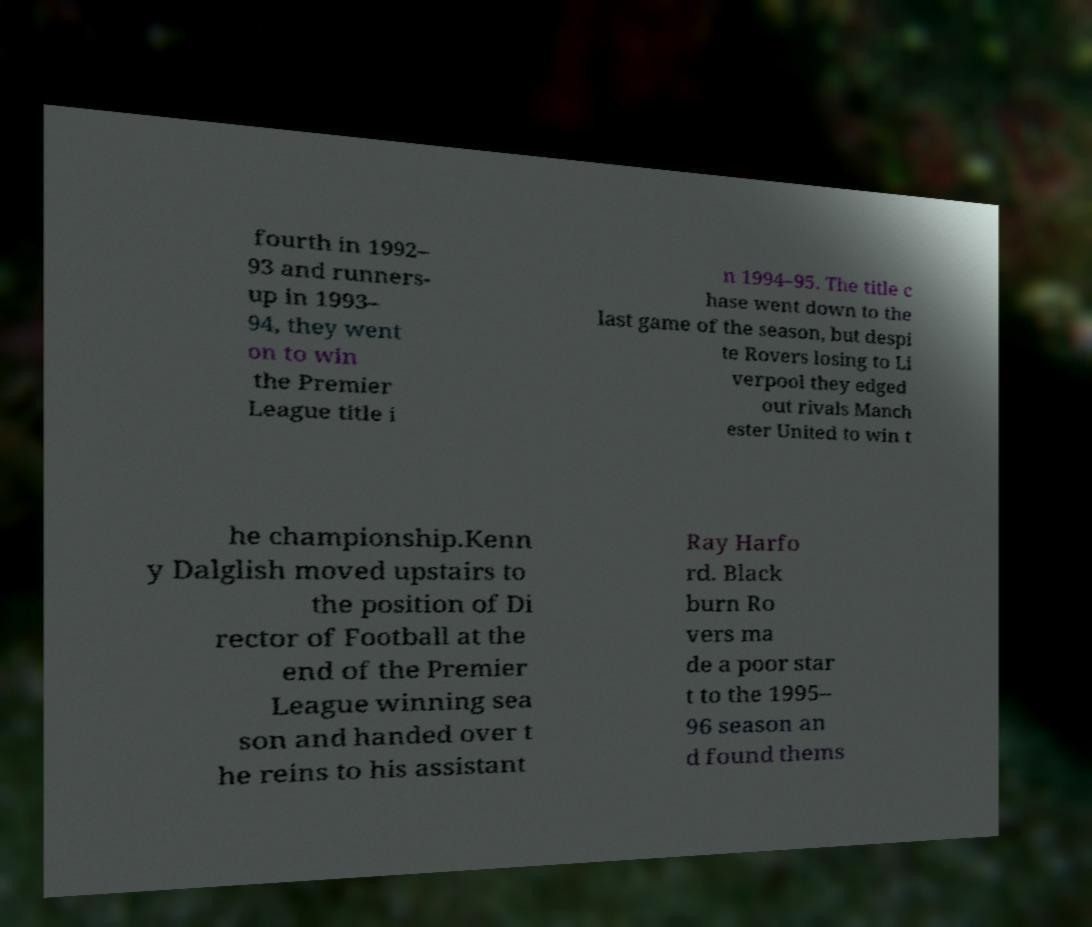For documentation purposes, I need the text within this image transcribed. Could you provide that? fourth in 1992– 93 and runners- up in 1993– 94, they went on to win the Premier League title i n 1994–95. The title c hase went down to the last game of the season, but despi te Rovers losing to Li verpool they edged out rivals Manch ester United to win t he championship.Kenn y Dalglish moved upstairs to the position of Di rector of Football at the end of the Premier League winning sea son and handed over t he reins to his assistant Ray Harfo rd. Black burn Ro vers ma de a poor star t to the 1995– 96 season an d found thems 